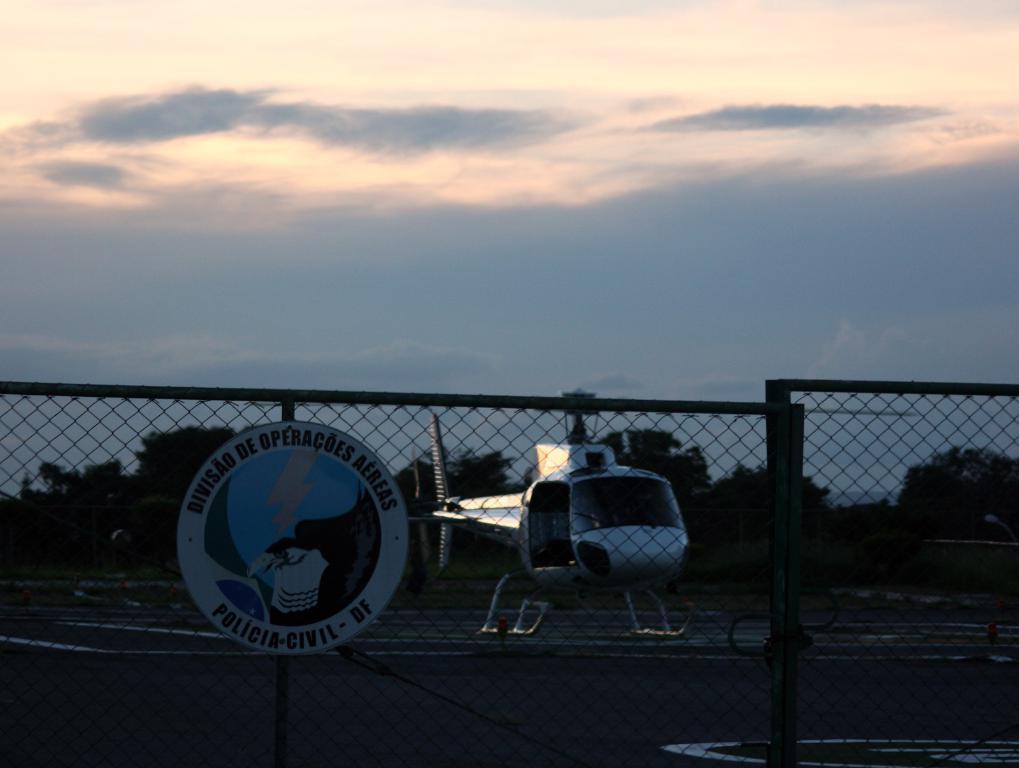Can you describe this image briefly? There is a fencing and behind of fencing there is a helicopter landing on the helipad and around ground there are a lot of trees, in the background there is a sky. 